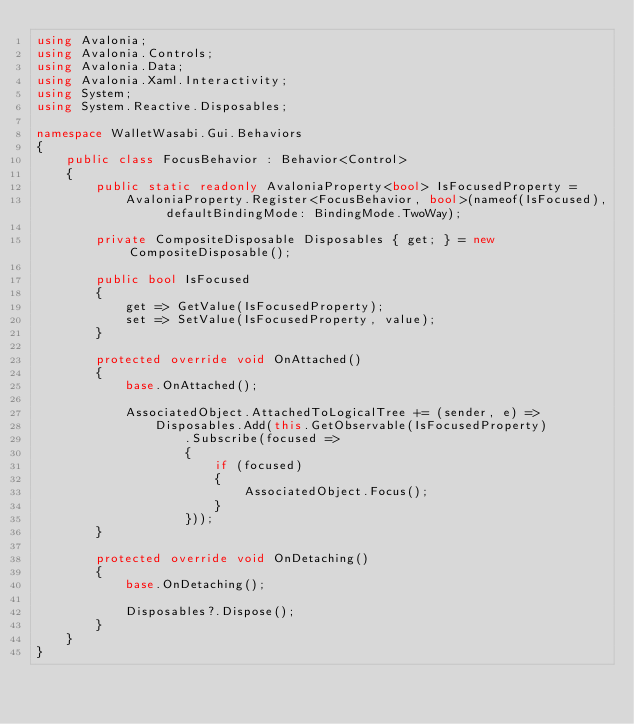<code> <loc_0><loc_0><loc_500><loc_500><_C#_>using Avalonia;
using Avalonia.Controls;
using Avalonia.Data;
using Avalonia.Xaml.Interactivity;
using System;
using System.Reactive.Disposables;

namespace WalletWasabi.Gui.Behaviors
{
	public class FocusBehavior : Behavior<Control>
	{
		public static readonly AvaloniaProperty<bool> IsFocusedProperty =
			AvaloniaProperty.Register<FocusBehavior, bool>(nameof(IsFocused), defaultBindingMode: BindingMode.TwoWay);

		private CompositeDisposable Disposables { get; } = new CompositeDisposable();

		public bool IsFocused
		{
			get => GetValue(IsFocusedProperty);
			set => SetValue(IsFocusedProperty, value);
		}

		protected override void OnAttached()
		{
			base.OnAttached();

			AssociatedObject.AttachedToLogicalTree += (sender, e) =>
				Disposables.Add(this.GetObservable(IsFocusedProperty)
					.Subscribe(focused =>
					{
						if (focused)
						{
							AssociatedObject.Focus();
						}
					}));
		}

		protected override void OnDetaching()
		{
			base.OnDetaching();

			Disposables?.Dispose();
		}
	}
}
</code> 